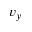Convert formula to latex. <formula><loc_0><loc_0><loc_500><loc_500>v _ { y }</formula> 